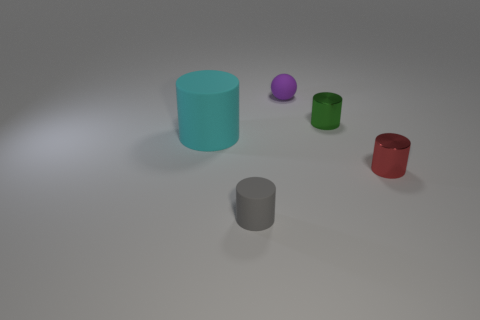Does the small gray object have the same shape as the small green object?
Your answer should be compact. Yes. How many blocks are either tiny red things or small yellow rubber objects?
Offer a terse response. 0. What color is the ball that is the same material as the big cyan object?
Your answer should be very brief. Purple. There is a matte thing in front of the cyan matte cylinder; is its size the same as the small red shiny thing?
Your answer should be compact. Yes. Is the red object made of the same material as the small cylinder that is on the left side of the tiny matte ball?
Your answer should be very brief. No. There is a metal cylinder that is behind the big object; what color is it?
Your answer should be very brief. Green. There is a cylinder in front of the small red cylinder; is there a big cyan rubber object that is in front of it?
Your answer should be very brief. No. There is a rubber object that is behind the tiny green cylinder; does it have the same color as the tiny object on the right side of the green thing?
Give a very brief answer. No. What number of big things are behind the green shiny thing?
Make the answer very short. 0. What number of shiny cylinders have the same color as the matte ball?
Ensure brevity in your answer.  0. 